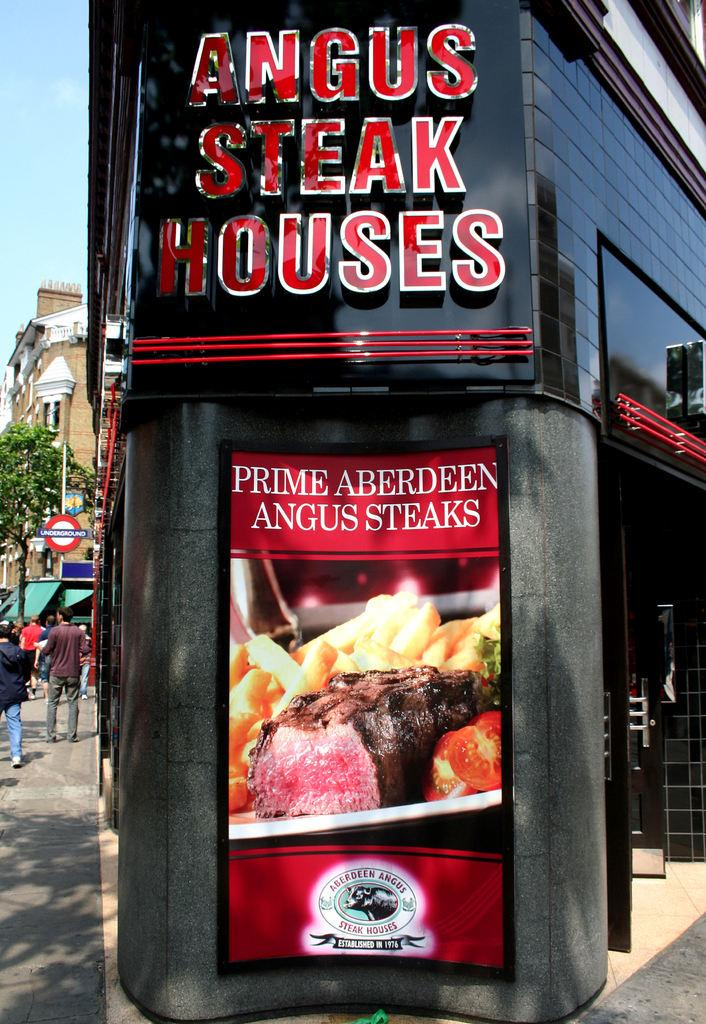<image>
Summarize the visual content of the image. The steakhouse serves Prime Aberseen Angus steaks per the sign. 